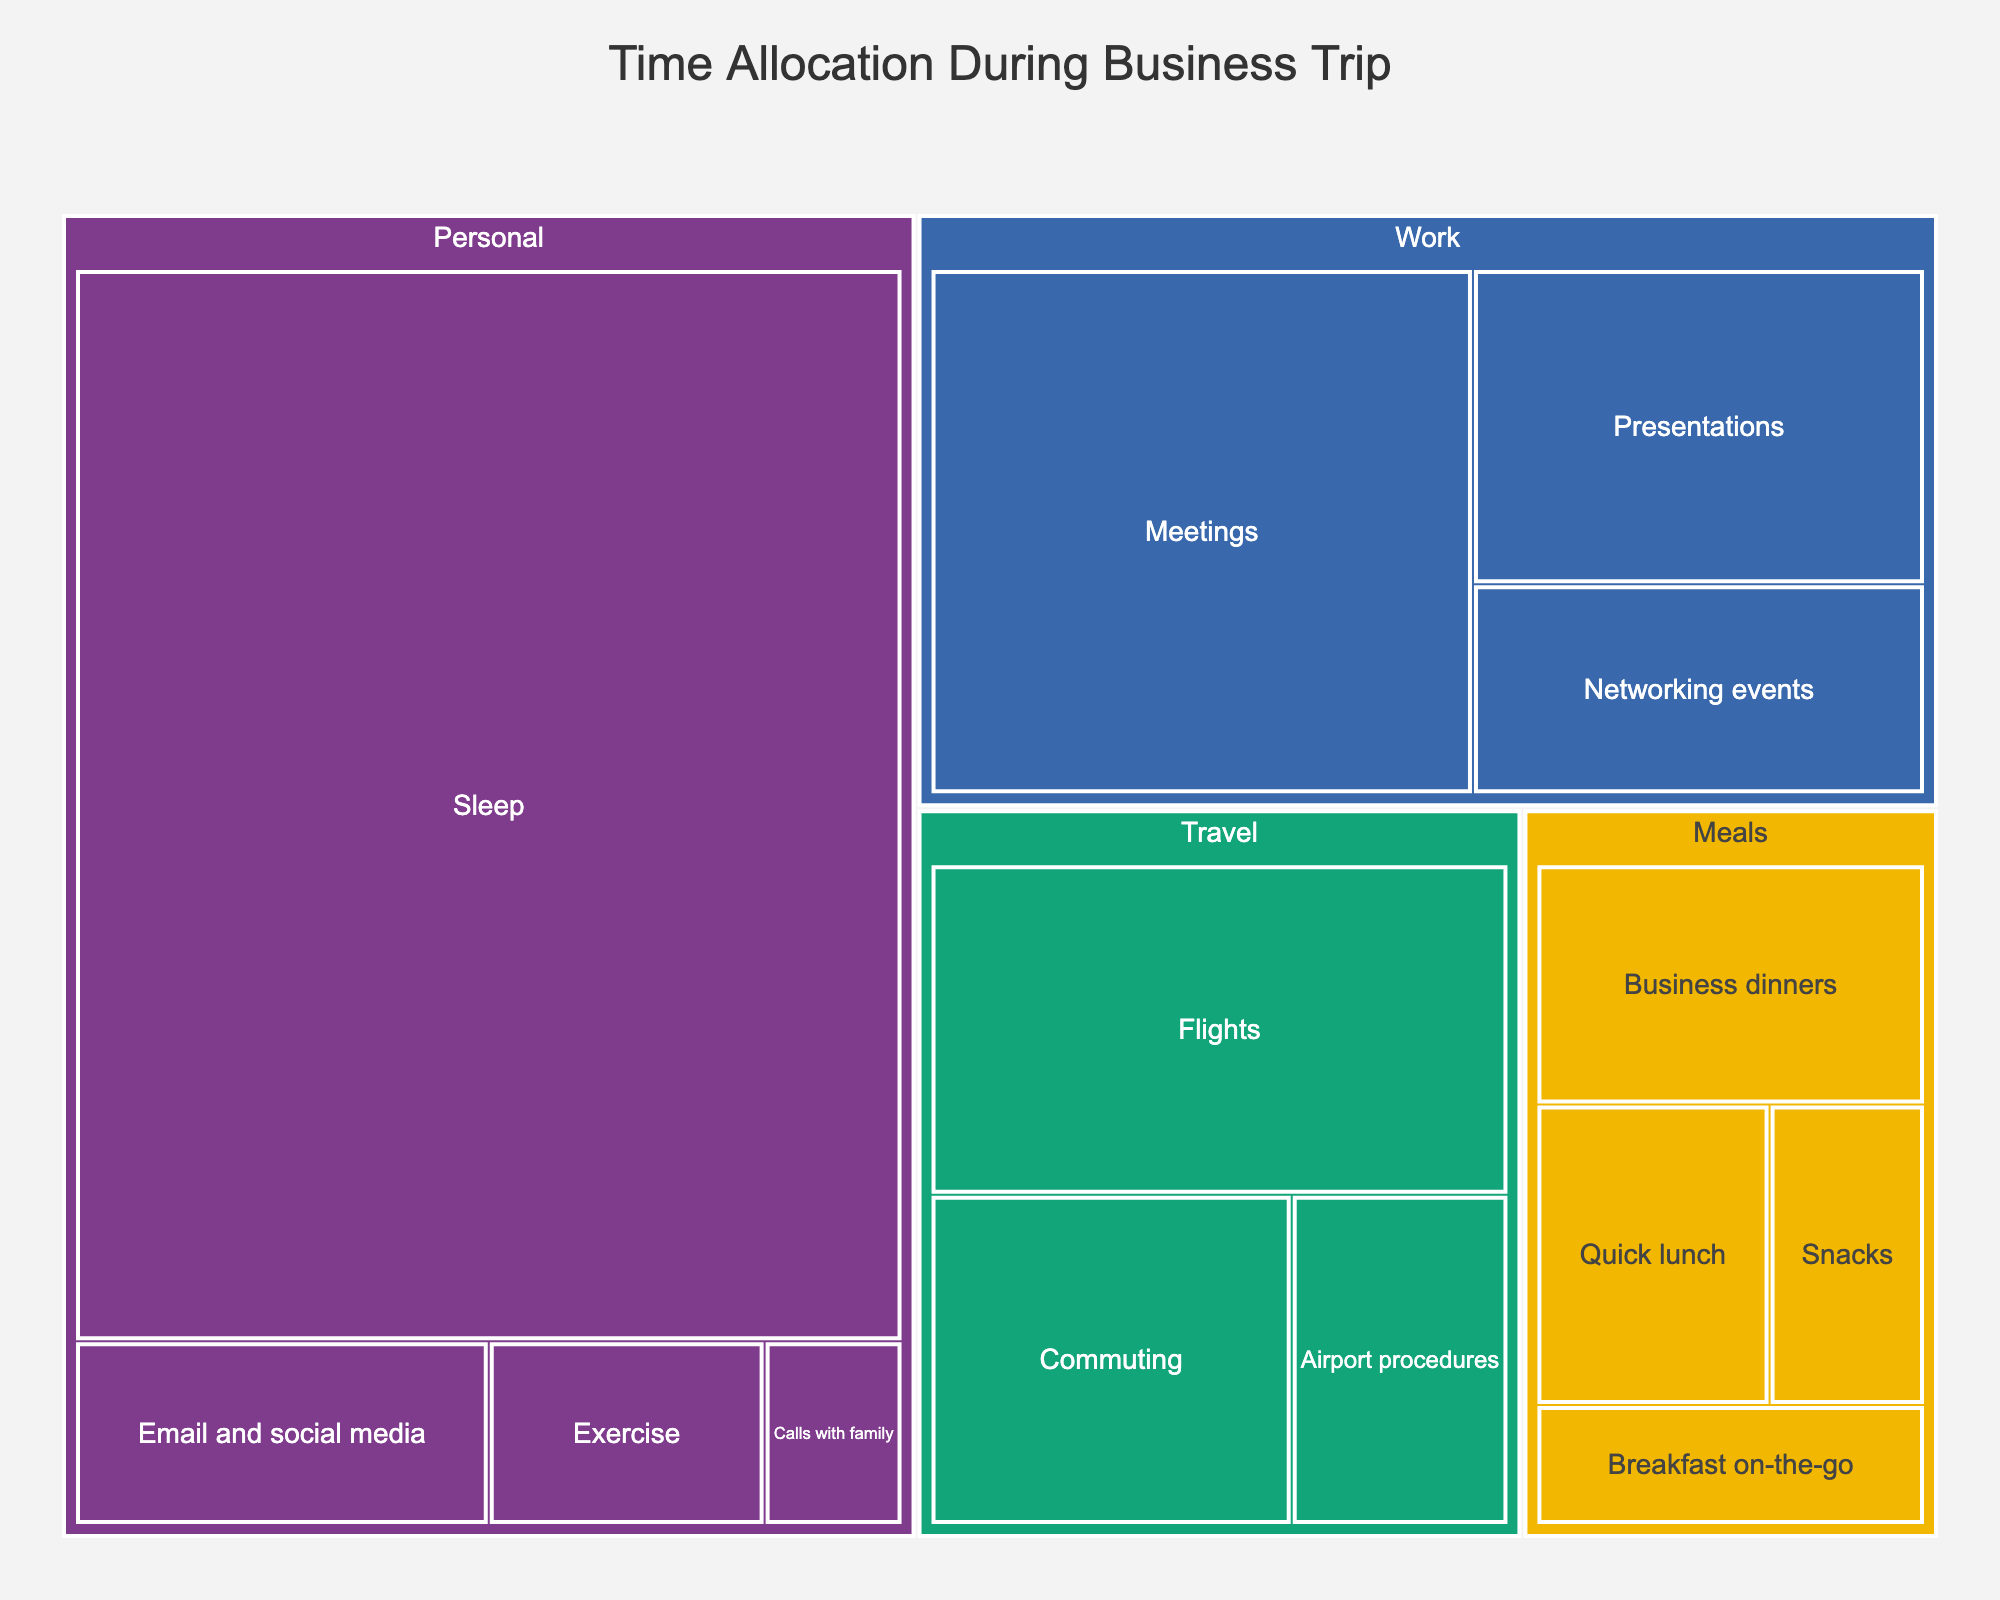What's the main focus of this treemap? The title of the treemap is "Time Allocation During Business Trip," indicating that it visualizes how time is spent on various activities during a business trip.
Answer: Time allocation during a business trip How many categories are displayed in the treemap? The treemap shows four categories: Work, Travel, Meals, and Personal.
Answer: Four What's the total time spent on work-related activities? To find the total time spent on work-related activities, sum the time for Meetings (12 hours), Presentations (6 hours), and Networking events (4 hours): 12 + 6 + 4 = 22 hours.
Answer: 22 hours Which category has the highest allocated time? By looking at the largest section in the treemap, the category "Personal" has the highest time allocation.
Answer: Personal How much time is spent on meals altogether? Add the time spent on Breakfast on-the-go (2 hours), Quick lunch (3 hours), Business dinners (4 hours), and Snacks (2 hours): 2 + 3 + 4 + 2 = 11 hours.
Answer: 11 hours What is the least time-consuming activity in the Personal category? By reviewing the Personal category in the treemap, the least time-consuming activity is Calls with family, which takes 1 hour.
Answer: Calls with family Compare the amount of time spent on Commuting versus Business dinners. Which one is higher? The treemap indicates that Commuting takes 5 hours and Business dinners take 4 hours. Therefore, more time is spent on Commuting.
Answer: Commuting What percentage of total travel time is spent in flights? First, calculate total travel time by adding Flights (8 hours), Commuting (5 hours), and Airport procedures (3 hours): 8 + 5 + 3 = 16 hours. Then, find the percentage of time spent in Flights: (8 / 16) * 100 = 50%.
Answer: 50% Identify two activities in the Personal category and compare their time allocations. Within the Personal category, compare Sleep (35 hours) and Exercise (2 hours). Sleep has a much higher time allocation than Exercise.
Answer: Sleep > Exercise Which activity takes a longer time, Quick lunch or Networking events? By examining the treemap, Quick lunch takes 3 hours while Networking events take 4 hours. Therefore, Networking events take longer.
Answer: Networking events 